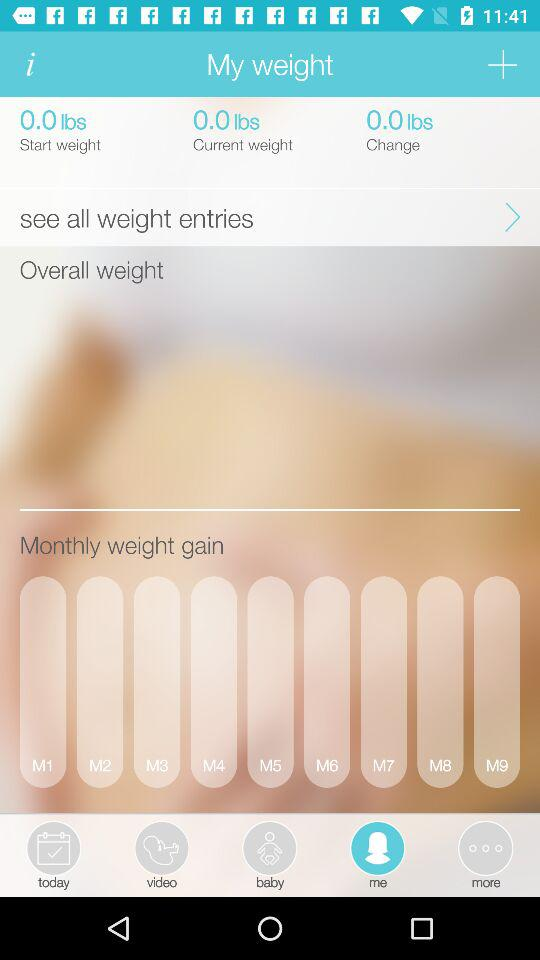What is the change in weight? The change in weight is 0 lbs. 